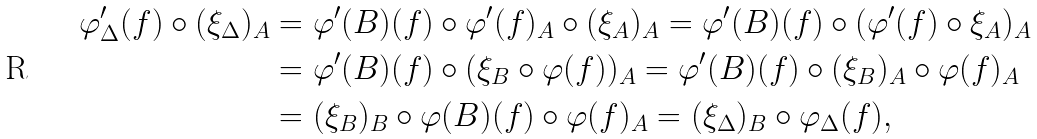Convert formula to latex. <formula><loc_0><loc_0><loc_500><loc_500>\varphi ^ { \prime } _ { \Delta } ( f ) \circ ( \xi _ { \Delta } ) _ { A } & = \varphi ^ { \prime } ( B ) ( f ) \circ \varphi ^ { \prime } ( f ) _ { A } \circ ( \xi _ { A } ) _ { A } = \varphi ^ { \prime } ( B ) ( f ) \circ ( \varphi ^ { \prime } ( f ) \circ \xi _ { A } ) _ { A } \\ & = \varphi ^ { \prime } ( B ) ( f ) \circ ( \xi _ { B } \circ \varphi ( f ) ) _ { A } = \varphi ^ { \prime } ( B ) ( f ) \circ ( \xi _ { B } ) _ { A } \circ \varphi ( f ) _ { A } \\ & = ( \xi _ { B } ) _ { B } \circ \varphi ( B ) ( f ) \circ \varphi ( f ) _ { A } = ( \xi _ { \Delta } ) _ { B } \circ \varphi _ { \Delta } ( f ) ,</formula> 